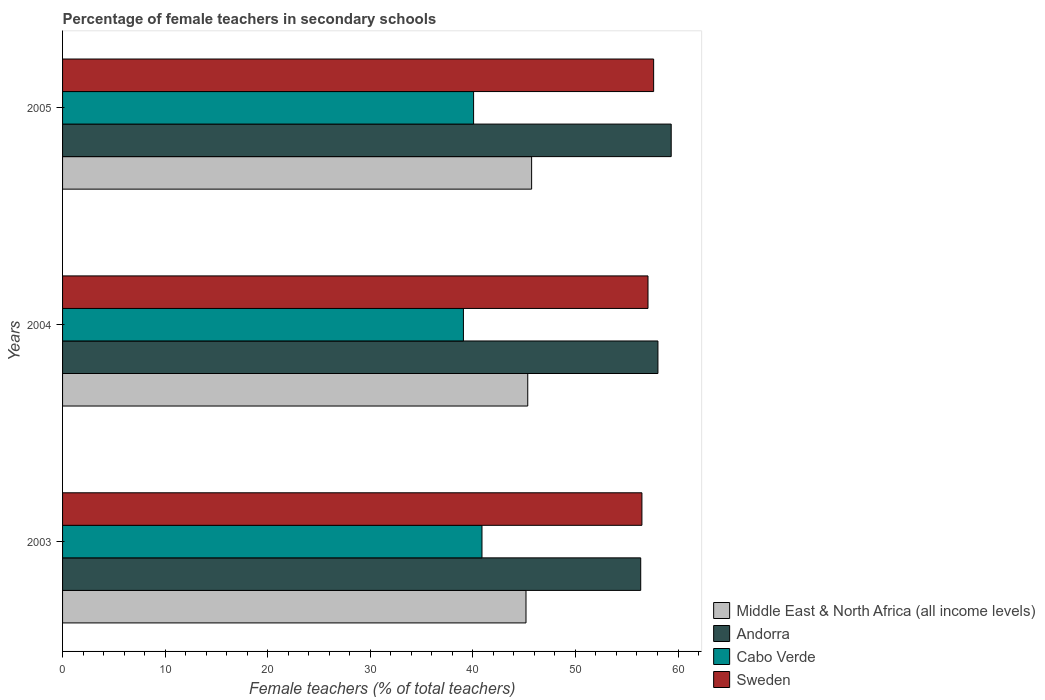How many different coloured bars are there?
Provide a short and direct response. 4. How many groups of bars are there?
Offer a terse response. 3. How many bars are there on the 1st tick from the bottom?
Keep it short and to the point. 4. What is the label of the 1st group of bars from the top?
Offer a terse response. 2005. In how many cases, is the number of bars for a given year not equal to the number of legend labels?
Your answer should be very brief. 0. What is the percentage of female teachers in Andorra in 2004?
Ensure brevity in your answer.  58.04. Across all years, what is the maximum percentage of female teachers in Sweden?
Provide a short and direct response. 57.62. Across all years, what is the minimum percentage of female teachers in Sweden?
Keep it short and to the point. 56.48. In which year was the percentage of female teachers in Andorra maximum?
Your answer should be very brief. 2005. In which year was the percentage of female teachers in Sweden minimum?
Your response must be concise. 2003. What is the total percentage of female teachers in Sweden in the graph?
Make the answer very short. 171.18. What is the difference between the percentage of female teachers in Middle East & North Africa (all income levels) in 2003 and that in 2005?
Your answer should be very brief. -0.55. What is the difference between the percentage of female teachers in Cabo Verde in 2004 and the percentage of female teachers in Andorra in 2005?
Keep it short and to the point. -20.26. What is the average percentage of female teachers in Andorra per year?
Make the answer very short. 57.91. In the year 2003, what is the difference between the percentage of female teachers in Andorra and percentage of female teachers in Sweden?
Offer a terse response. -0.12. What is the ratio of the percentage of female teachers in Andorra in 2004 to that in 2005?
Provide a short and direct response. 0.98. What is the difference between the highest and the second highest percentage of female teachers in Cabo Verde?
Make the answer very short. 0.82. What is the difference between the highest and the lowest percentage of female teachers in Sweden?
Provide a succinct answer. 1.14. In how many years, is the percentage of female teachers in Andorra greater than the average percentage of female teachers in Andorra taken over all years?
Give a very brief answer. 2. What does the 4th bar from the top in 2004 represents?
Your answer should be very brief. Middle East & North Africa (all income levels). What does the 2nd bar from the bottom in 2005 represents?
Ensure brevity in your answer.  Andorra. Is it the case that in every year, the sum of the percentage of female teachers in Andorra and percentage of female teachers in Cabo Verde is greater than the percentage of female teachers in Middle East & North Africa (all income levels)?
Ensure brevity in your answer.  Yes. How many bars are there?
Your answer should be compact. 12. Are all the bars in the graph horizontal?
Offer a very short reply. Yes. How many years are there in the graph?
Your answer should be very brief. 3. What is the difference between two consecutive major ticks on the X-axis?
Your answer should be very brief. 10. Are the values on the major ticks of X-axis written in scientific E-notation?
Your answer should be compact. No. Does the graph contain grids?
Your answer should be compact. No. Where does the legend appear in the graph?
Offer a terse response. Bottom right. What is the title of the graph?
Ensure brevity in your answer.  Percentage of female teachers in secondary schools. What is the label or title of the X-axis?
Your answer should be very brief. Female teachers (% of total teachers). What is the label or title of the Y-axis?
Provide a short and direct response. Years. What is the Female teachers (% of total teachers) of Middle East & North Africa (all income levels) in 2003?
Your answer should be very brief. 45.18. What is the Female teachers (% of total teachers) in Andorra in 2003?
Offer a very short reply. 56.36. What is the Female teachers (% of total teachers) of Cabo Verde in 2003?
Provide a short and direct response. 40.89. What is the Female teachers (% of total teachers) of Sweden in 2003?
Your answer should be compact. 56.48. What is the Female teachers (% of total teachers) in Middle East & North Africa (all income levels) in 2004?
Offer a terse response. 45.35. What is the Female teachers (% of total teachers) in Andorra in 2004?
Your answer should be very brief. 58.04. What is the Female teachers (% of total teachers) in Cabo Verde in 2004?
Your response must be concise. 39.08. What is the Female teachers (% of total teachers) in Sweden in 2004?
Provide a succinct answer. 57.07. What is the Female teachers (% of total teachers) in Middle East & North Africa (all income levels) in 2005?
Your answer should be very brief. 45.73. What is the Female teachers (% of total teachers) in Andorra in 2005?
Offer a terse response. 59.34. What is the Female teachers (% of total teachers) in Cabo Verde in 2005?
Offer a very short reply. 40.07. What is the Female teachers (% of total teachers) of Sweden in 2005?
Keep it short and to the point. 57.62. Across all years, what is the maximum Female teachers (% of total teachers) in Middle East & North Africa (all income levels)?
Provide a succinct answer. 45.73. Across all years, what is the maximum Female teachers (% of total teachers) in Andorra?
Make the answer very short. 59.34. Across all years, what is the maximum Female teachers (% of total teachers) in Cabo Verde?
Provide a succinct answer. 40.89. Across all years, what is the maximum Female teachers (% of total teachers) of Sweden?
Offer a terse response. 57.62. Across all years, what is the minimum Female teachers (% of total teachers) of Middle East & North Africa (all income levels)?
Provide a succinct answer. 45.18. Across all years, what is the minimum Female teachers (% of total teachers) of Andorra?
Provide a short and direct response. 56.36. Across all years, what is the minimum Female teachers (% of total teachers) in Cabo Verde?
Make the answer very short. 39.08. Across all years, what is the minimum Female teachers (% of total teachers) of Sweden?
Offer a terse response. 56.48. What is the total Female teachers (% of total teachers) in Middle East & North Africa (all income levels) in the graph?
Ensure brevity in your answer.  136.26. What is the total Female teachers (% of total teachers) in Andorra in the graph?
Offer a very short reply. 173.74. What is the total Female teachers (% of total teachers) of Cabo Verde in the graph?
Ensure brevity in your answer.  120.04. What is the total Female teachers (% of total teachers) in Sweden in the graph?
Offer a very short reply. 171.18. What is the difference between the Female teachers (% of total teachers) in Middle East & North Africa (all income levels) in 2003 and that in 2004?
Your response must be concise. -0.17. What is the difference between the Female teachers (% of total teachers) in Andorra in 2003 and that in 2004?
Keep it short and to the point. -1.68. What is the difference between the Female teachers (% of total teachers) of Cabo Verde in 2003 and that in 2004?
Your answer should be compact. 1.81. What is the difference between the Female teachers (% of total teachers) of Sweden in 2003 and that in 2004?
Offer a very short reply. -0.59. What is the difference between the Female teachers (% of total teachers) of Middle East & North Africa (all income levels) in 2003 and that in 2005?
Make the answer very short. -0.55. What is the difference between the Female teachers (% of total teachers) of Andorra in 2003 and that in 2005?
Keep it short and to the point. -2.97. What is the difference between the Female teachers (% of total teachers) of Cabo Verde in 2003 and that in 2005?
Provide a short and direct response. 0.82. What is the difference between the Female teachers (% of total teachers) in Sweden in 2003 and that in 2005?
Your answer should be very brief. -1.14. What is the difference between the Female teachers (% of total teachers) in Middle East & North Africa (all income levels) in 2004 and that in 2005?
Your answer should be very brief. -0.38. What is the difference between the Female teachers (% of total teachers) of Andorra in 2004 and that in 2005?
Offer a very short reply. -1.29. What is the difference between the Female teachers (% of total teachers) in Cabo Verde in 2004 and that in 2005?
Your answer should be very brief. -0.99. What is the difference between the Female teachers (% of total teachers) in Sweden in 2004 and that in 2005?
Your answer should be very brief. -0.55. What is the difference between the Female teachers (% of total teachers) of Middle East & North Africa (all income levels) in 2003 and the Female teachers (% of total teachers) of Andorra in 2004?
Keep it short and to the point. -12.86. What is the difference between the Female teachers (% of total teachers) of Middle East & North Africa (all income levels) in 2003 and the Female teachers (% of total teachers) of Cabo Verde in 2004?
Offer a terse response. 6.1. What is the difference between the Female teachers (% of total teachers) of Middle East & North Africa (all income levels) in 2003 and the Female teachers (% of total teachers) of Sweden in 2004?
Ensure brevity in your answer.  -11.89. What is the difference between the Female teachers (% of total teachers) of Andorra in 2003 and the Female teachers (% of total teachers) of Cabo Verde in 2004?
Keep it short and to the point. 17.28. What is the difference between the Female teachers (% of total teachers) of Andorra in 2003 and the Female teachers (% of total teachers) of Sweden in 2004?
Give a very brief answer. -0.71. What is the difference between the Female teachers (% of total teachers) of Cabo Verde in 2003 and the Female teachers (% of total teachers) of Sweden in 2004?
Keep it short and to the point. -16.18. What is the difference between the Female teachers (% of total teachers) of Middle East & North Africa (all income levels) in 2003 and the Female teachers (% of total teachers) of Andorra in 2005?
Your answer should be compact. -14.16. What is the difference between the Female teachers (% of total teachers) in Middle East & North Africa (all income levels) in 2003 and the Female teachers (% of total teachers) in Cabo Verde in 2005?
Provide a short and direct response. 5.11. What is the difference between the Female teachers (% of total teachers) in Middle East & North Africa (all income levels) in 2003 and the Female teachers (% of total teachers) in Sweden in 2005?
Provide a succinct answer. -12.44. What is the difference between the Female teachers (% of total teachers) in Andorra in 2003 and the Female teachers (% of total teachers) in Cabo Verde in 2005?
Your answer should be very brief. 16.29. What is the difference between the Female teachers (% of total teachers) of Andorra in 2003 and the Female teachers (% of total teachers) of Sweden in 2005?
Make the answer very short. -1.26. What is the difference between the Female teachers (% of total teachers) of Cabo Verde in 2003 and the Female teachers (% of total teachers) of Sweden in 2005?
Your response must be concise. -16.73. What is the difference between the Female teachers (% of total teachers) of Middle East & North Africa (all income levels) in 2004 and the Female teachers (% of total teachers) of Andorra in 2005?
Offer a very short reply. -13.99. What is the difference between the Female teachers (% of total teachers) in Middle East & North Africa (all income levels) in 2004 and the Female teachers (% of total teachers) in Cabo Verde in 2005?
Keep it short and to the point. 5.28. What is the difference between the Female teachers (% of total teachers) of Middle East & North Africa (all income levels) in 2004 and the Female teachers (% of total teachers) of Sweden in 2005?
Offer a very short reply. -12.27. What is the difference between the Female teachers (% of total teachers) in Andorra in 2004 and the Female teachers (% of total teachers) in Cabo Verde in 2005?
Ensure brevity in your answer.  17.97. What is the difference between the Female teachers (% of total teachers) of Andorra in 2004 and the Female teachers (% of total teachers) of Sweden in 2005?
Provide a succinct answer. 0.42. What is the difference between the Female teachers (% of total teachers) in Cabo Verde in 2004 and the Female teachers (% of total teachers) in Sweden in 2005?
Ensure brevity in your answer.  -18.54. What is the average Female teachers (% of total teachers) in Middle East & North Africa (all income levels) per year?
Offer a very short reply. 45.42. What is the average Female teachers (% of total teachers) in Andorra per year?
Offer a terse response. 57.91. What is the average Female teachers (% of total teachers) of Cabo Verde per year?
Your answer should be very brief. 40.01. What is the average Female teachers (% of total teachers) of Sweden per year?
Ensure brevity in your answer.  57.06. In the year 2003, what is the difference between the Female teachers (% of total teachers) in Middle East & North Africa (all income levels) and Female teachers (% of total teachers) in Andorra?
Your answer should be compact. -11.18. In the year 2003, what is the difference between the Female teachers (% of total teachers) of Middle East & North Africa (all income levels) and Female teachers (% of total teachers) of Cabo Verde?
Provide a short and direct response. 4.29. In the year 2003, what is the difference between the Female teachers (% of total teachers) in Middle East & North Africa (all income levels) and Female teachers (% of total teachers) in Sweden?
Provide a succinct answer. -11.3. In the year 2003, what is the difference between the Female teachers (% of total teachers) of Andorra and Female teachers (% of total teachers) of Cabo Verde?
Give a very brief answer. 15.47. In the year 2003, what is the difference between the Female teachers (% of total teachers) of Andorra and Female teachers (% of total teachers) of Sweden?
Make the answer very short. -0.12. In the year 2003, what is the difference between the Female teachers (% of total teachers) of Cabo Verde and Female teachers (% of total teachers) of Sweden?
Offer a very short reply. -15.59. In the year 2004, what is the difference between the Female teachers (% of total teachers) of Middle East & North Africa (all income levels) and Female teachers (% of total teachers) of Andorra?
Your answer should be very brief. -12.69. In the year 2004, what is the difference between the Female teachers (% of total teachers) of Middle East & North Africa (all income levels) and Female teachers (% of total teachers) of Cabo Verde?
Your answer should be compact. 6.27. In the year 2004, what is the difference between the Female teachers (% of total teachers) of Middle East & North Africa (all income levels) and Female teachers (% of total teachers) of Sweden?
Make the answer very short. -11.72. In the year 2004, what is the difference between the Female teachers (% of total teachers) in Andorra and Female teachers (% of total teachers) in Cabo Verde?
Make the answer very short. 18.96. In the year 2004, what is the difference between the Female teachers (% of total teachers) in Andorra and Female teachers (% of total teachers) in Sweden?
Make the answer very short. 0.97. In the year 2004, what is the difference between the Female teachers (% of total teachers) of Cabo Verde and Female teachers (% of total teachers) of Sweden?
Offer a terse response. -17.99. In the year 2005, what is the difference between the Female teachers (% of total teachers) of Middle East & North Africa (all income levels) and Female teachers (% of total teachers) of Andorra?
Provide a short and direct response. -13.61. In the year 2005, what is the difference between the Female teachers (% of total teachers) in Middle East & North Africa (all income levels) and Female teachers (% of total teachers) in Cabo Verde?
Provide a succinct answer. 5.66. In the year 2005, what is the difference between the Female teachers (% of total teachers) of Middle East & North Africa (all income levels) and Female teachers (% of total teachers) of Sweden?
Offer a very short reply. -11.89. In the year 2005, what is the difference between the Female teachers (% of total teachers) in Andorra and Female teachers (% of total teachers) in Cabo Verde?
Make the answer very short. 19.26. In the year 2005, what is the difference between the Female teachers (% of total teachers) in Andorra and Female teachers (% of total teachers) in Sweden?
Keep it short and to the point. 1.71. In the year 2005, what is the difference between the Female teachers (% of total teachers) in Cabo Verde and Female teachers (% of total teachers) in Sweden?
Your answer should be compact. -17.55. What is the ratio of the Female teachers (% of total teachers) in Andorra in 2003 to that in 2004?
Offer a terse response. 0.97. What is the ratio of the Female teachers (% of total teachers) of Cabo Verde in 2003 to that in 2004?
Provide a short and direct response. 1.05. What is the ratio of the Female teachers (% of total teachers) in Sweden in 2003 to that in 2004?
Your answer should be very brief. 0.99. What is the ratio of the Female teachers (% of total teachers) in Middle East & North Africa (all income levels) in 2003 to that in 2005?
Make the answer very short. 0.99. What is the ratio of the Female teachers (% of total teachers) in Andorra in 2003 to that in 2005?
Provide a short and direct response. 0.95. What is the ratio of the Female teachers (% of total teachers) of Cabo Verde in 2003 to that in 2005?
Give a very brief answer. 1.02. What is the ratio of the Female teachers (% of total teachers) of Sweden in 2003 to that in 2005?
Make the answer very short. 0.98. What is the ratio of the Female teachers (% of total teachers) of Middle East & North Africa (all income levels) in 2004 to that in 2005?
Offer a very short reply. 0.99. What is the ratio of the Female teachers (% of total teachers) in Andorra in 2004 to that in 2005?
Your answer should be very brief. 0.98. What is the ratio of the Female teachers (% of total teachers) of Cabo Verde in 2004 to that in 2005?
Make the answer very short. 0.98. What is the ratio of the Female teachers (% of total teachers) of Sweden in 2004 to that in 2005?
Offer a very short reply. 0.99. What is the difference between the highest and the second highest Female teachers (% of total teachers) of Middle East & North Africa (all income levels)?
Offer a very short reply. 0.38. What is the difference between the highest and the second highest Female teachers (% of total teachers) of Andorra?
Make the answer very short. 1.29. What is the difference between the highest and the second highest Female teachers (% of total teachers) in Cabo Verde?
Your answer should be very brief. 0.82. What is the difference between the highest and the second highest Female teachers (% of total teachers) of Sweden?
Your answer should be compact. 0.55. What is the difference between the highest and the lowest Female teachers (% of total teachers) of Middle East & North Africa (all income levels)?
Ensure brevity in your answer.  0.55. What is the difference between the highest and the lowest Female teachers (% of total teachers) of Andorra?
Your answer should be compact. 2.97. What is the difference between the highest and the lowest Female teachers (% of total teachers) of Cabo Verde?
Offer a terse response. 1.81. What is the difference between the highest and the lowest Female teachers (% of total teachers) in Sweden?
Your answer should be compact. 1.14. 